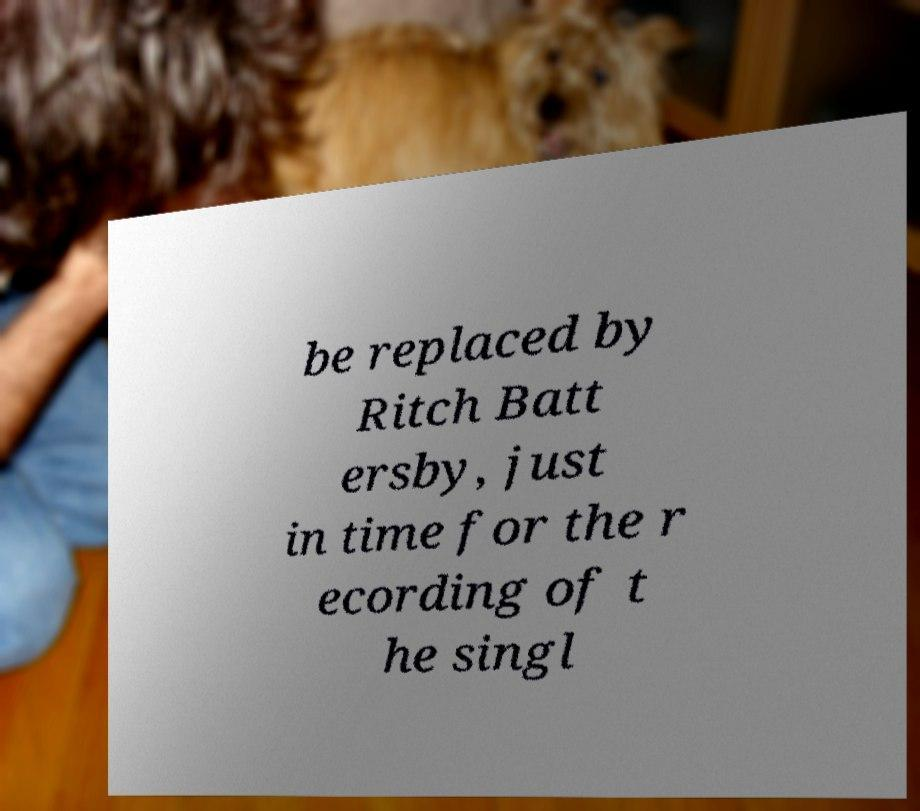Can you read and provide the text displayed in the image?This photo seems to have some interesting text. Can you extract and type it out for me? be replaced by Ritch Batt ersby, just in time for the r ecording of t he singl 